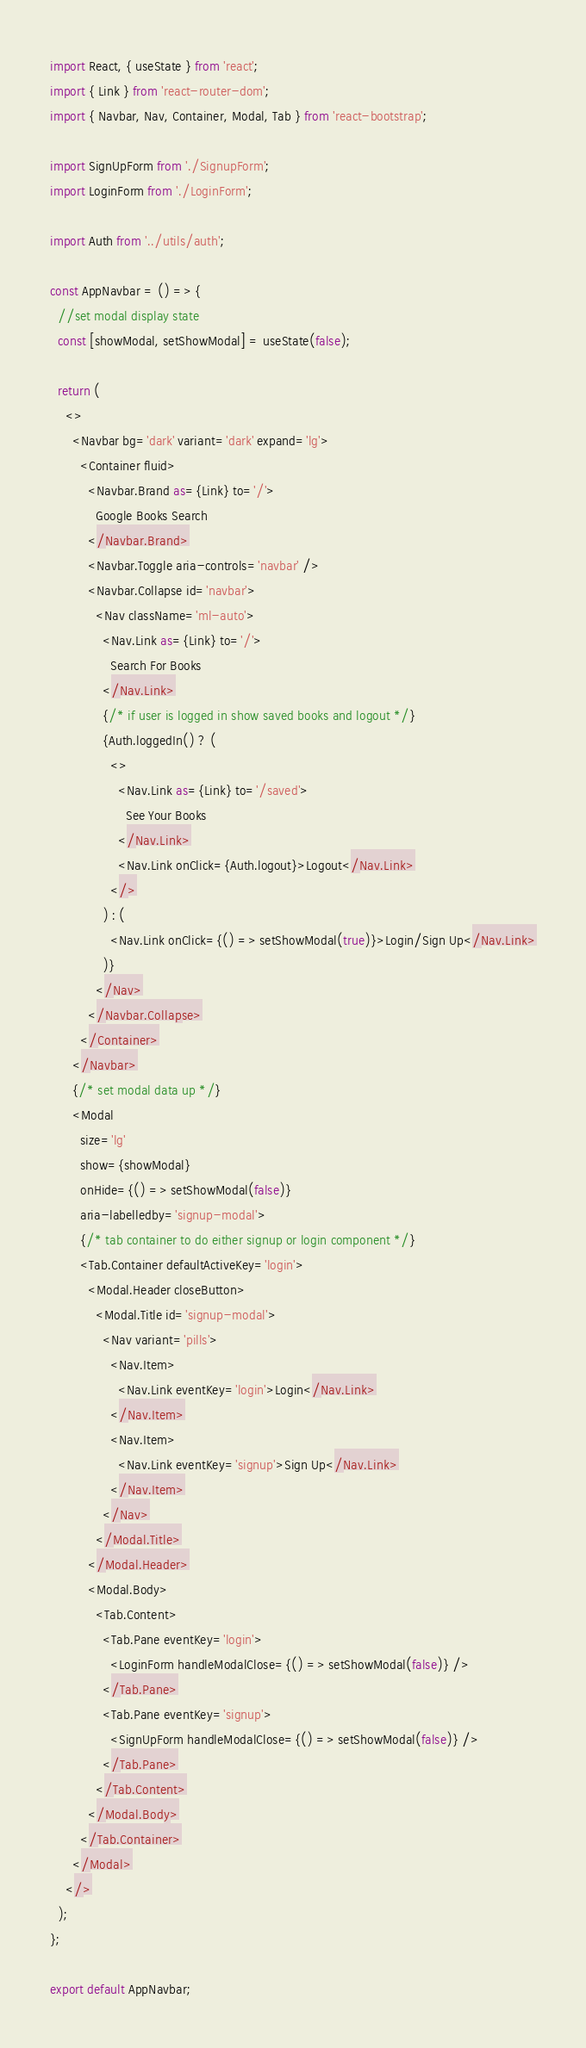<code> <loc_0><loc_0><loc_500><loc_500><_JavaScript_>import React, { useState } from 'react';
import { Link } from 'react-router-dom';
import { Navbar, Nav, Container, Modal, Tab } from 'react-bootstrap';

import SignUpForm from './SignupForm';
import LoginForm from './LoginForm';

import Auth from '../utils/auth';

const AppNavbar = () => {
  //set modal display state
  const [showModal, setShowModal] = useState(false);

  return (
    <>
      <Navbar bg='dark' variant='dark' expand='lg'>
        <Container fluid>
          <Navbar.Brand as={Link} to='/'>
            Google Books Search
          </Navbar.Brand>
          <Navbar.Toggle aria-controls='navbar' />
          <Navbar.Collapse id='navbar'>
            <Nav className='ml-auto'>
              <Nav.Link as={Link} to='/'>
                Search For Books
              </Nav.Link>
              {/* if user is logged in show saved books and logout */}
              {Auth.loggedIn() ? (
                <>
                  <Nav.Link as={Link} to='/saved'>
                    See Your Books
                  </Nav.Link>
                  <Nav.Link onClick={Auth.logout}>Logout</Nav.Link>
                </>
              ) : (
                <Nav.Link onClick={() => setShowModal(true)}>Login/Sign Up</Nav.Link>
              )}
            </Nav>
          </Navbar.Collapse>
        </Container>
      </Navbar>
      {/* set modal data up */}
      <Modal
        size='lg'
        show={showModal}
        onHide={() => setShowModal(false)}
        aria-labelledby='signup-modal'>
        {/* tab container to do either signup or login component */}
        <Tab.Container defaultActiveKey='login'>
          <Modal.Header closeButton>
            <Modal.Title id='signup-modal'>
              <Nav variant='pills'>
                <Nav.Item>
                  <Nav.Link eventKey='login'>Login</Nav.Link>
                </Nav.Item>
                <Nav.Item>
                  <Nav.Link eventKey='signup'>Sign Up</Nav.Link>
                </Nav.Item>
              </Nav>
            </Modal.Title>
          </Modal.Header>
          <Modal.Body>
            <Tab.Content>
              <Tab.Pane eventKey='login'>
                <LoginForm handleModalClose={() => setShowModal(false)} />
              </Tab.Pane>
              <Tab.Pane eventKey='signup'>
                <SignUpForm handleModalClose={() => setShowModal(false)} />
              </Tab.Pane>
            </Tab.Content>
          </Modal.Body>
        </Tab.Container>
      </Modal>
    </>
  );
};

export default AppNavbar;</code> 